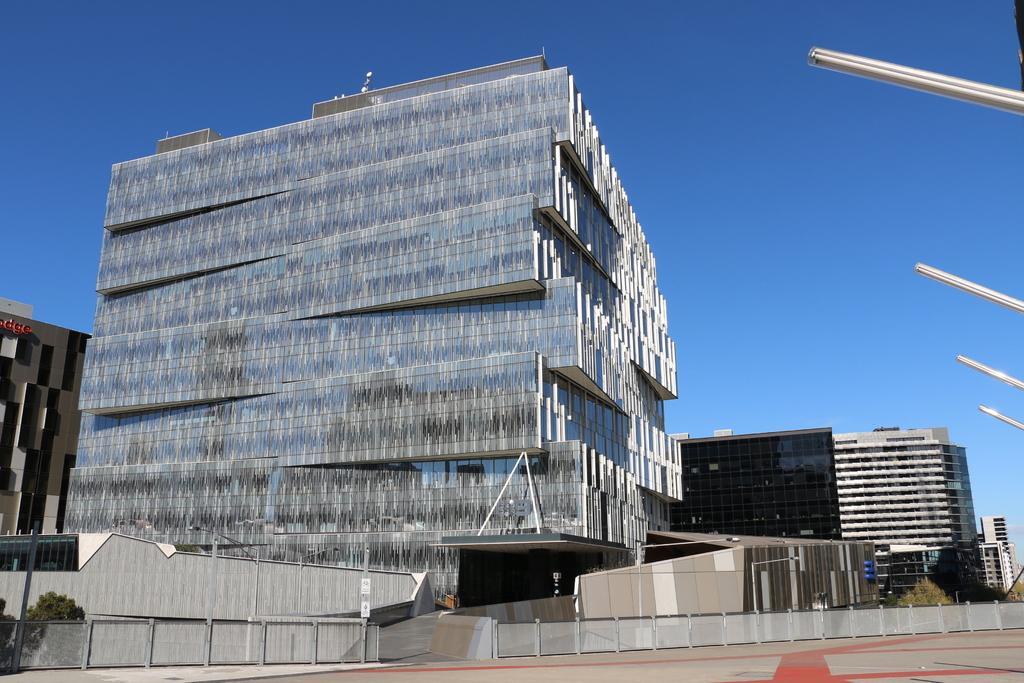Can you describe this image briefly? In this picture I can see buildings, there are trees, there is fence, and in the background there is the sky. 